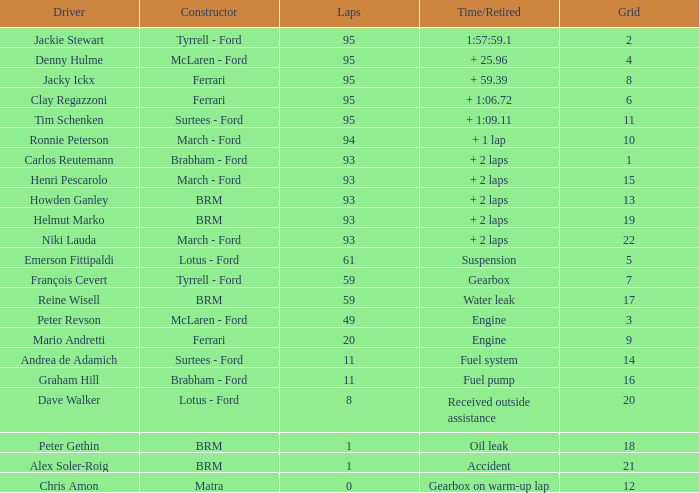What is the largest number of laps with a Grid larger than 14, a Time/Retired of + 2 laps, and a Driver of helmut marko? 93.0. 